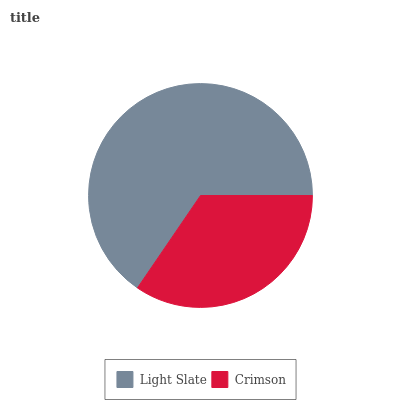Is Crimson the minimum?
Answer yes or no. Yes. Is Light Slate the maximum?
Answer yes or no. Yes. Is Crimson the maximum?
Answer yes or no. No. Is Light Slate greater than Crimson?
Answer yes or no. Yes. Is Crimson less than Light Slate?
Answer yes or no. Yes. Is Crimson greater than Light Slate?
Answer yes or no. No. Is Light Slate less than Crimson?
Answer yes or no. No. Is Light Slate the high median?
Answer yes or no. Yes. Is Crimson the low median?
Answer yes or no. Yes. Is Crimson the high median?
Answer yes or no. No. Is Light Slate the low median?
Answer yes or no. No. 